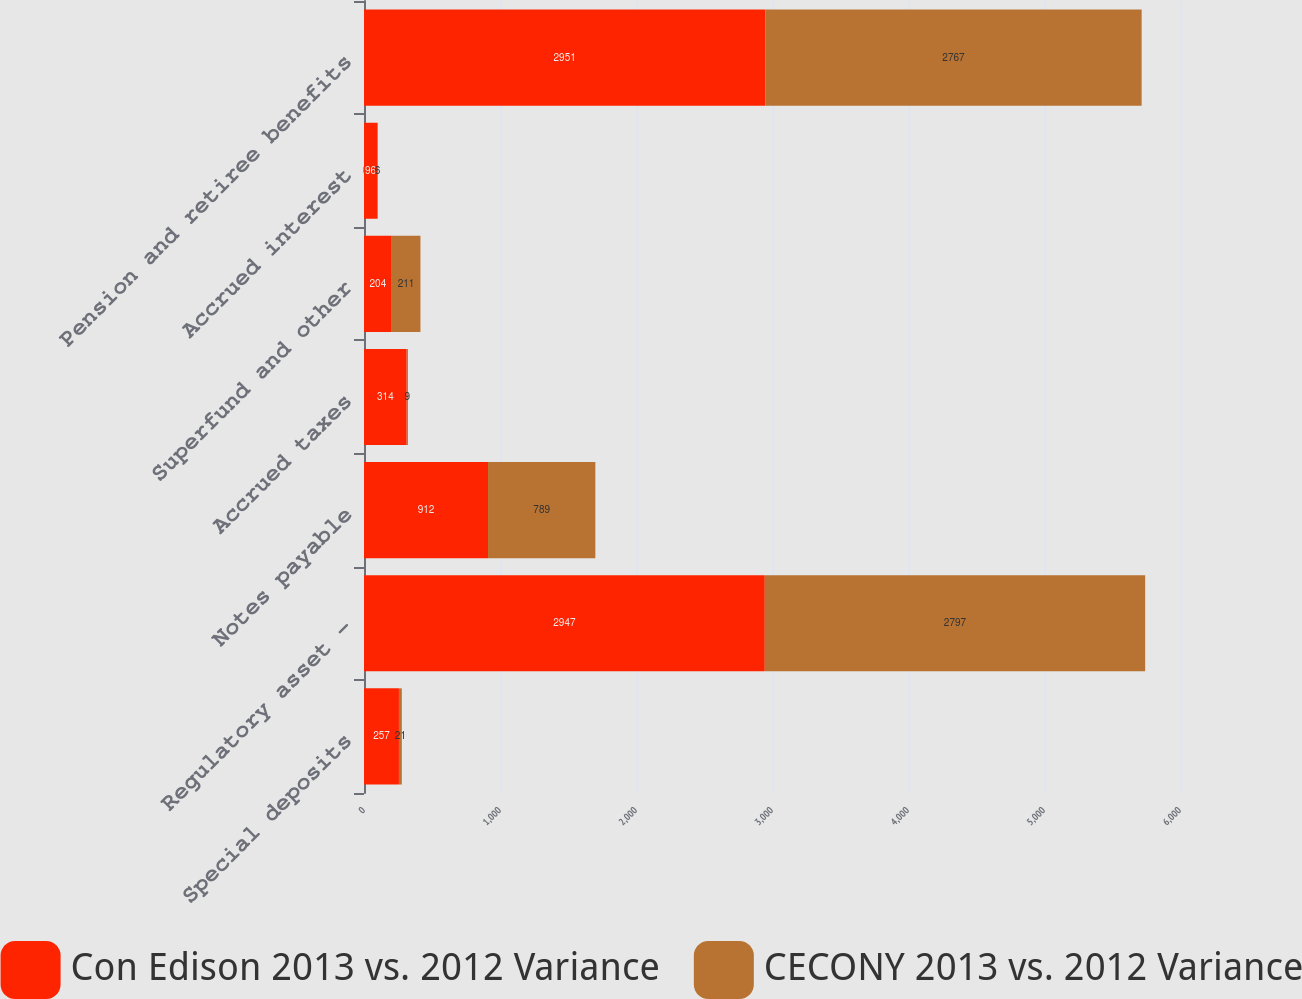Convert chart to OTSL. <chart><loc_0><loc_0><loc_500><loc_500><stacked_bar_chart><ecel><fcel>Special deposits<fcel>Regulatory asset -<fcel>Notes payable<fcel>Accrued taxes<fcel>Superfund and other<fcel>Accrued interest<fcel>Pension and retiree benefits<nl><fcel>Con Edison 2013 vs. 2012 Variance<fcel>257<fcel>2947<fcel>912<fcel>314<fcel>204<fcel>96<fcel>2951<nl><fcel>CECONY 2013 vs. 2012 Variance<fcel>21<fcel>2797<fcel>789<fcel>9<fcel>211<fcel>6<fcel>2767<nl></chart> 